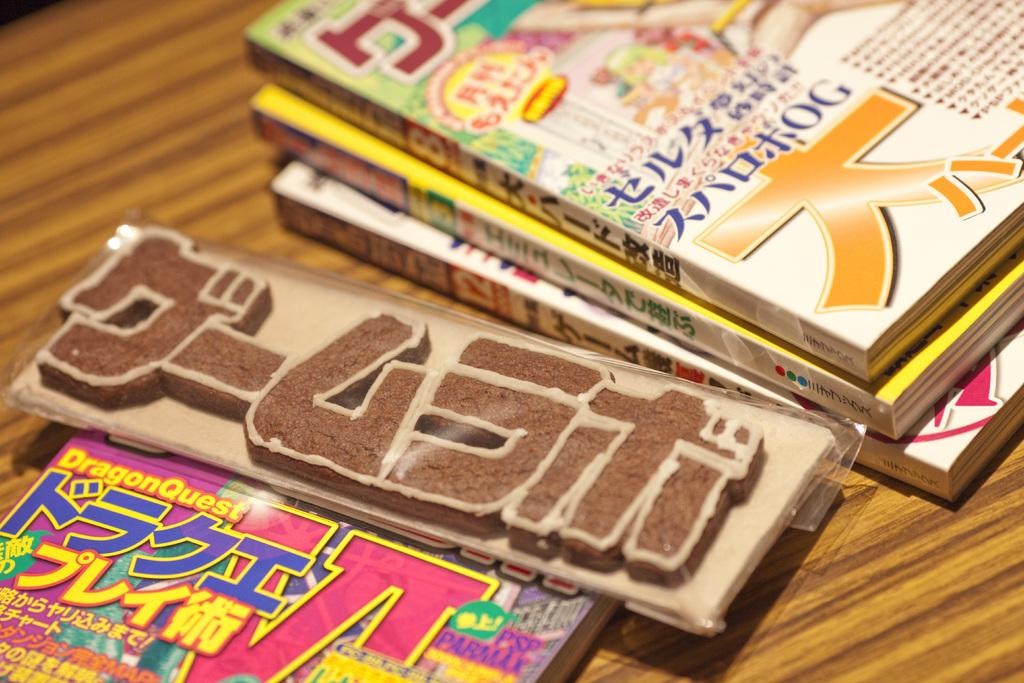<image>
Summarize the visual content of the image. Four different magazines written in japanese with a sign in between. 